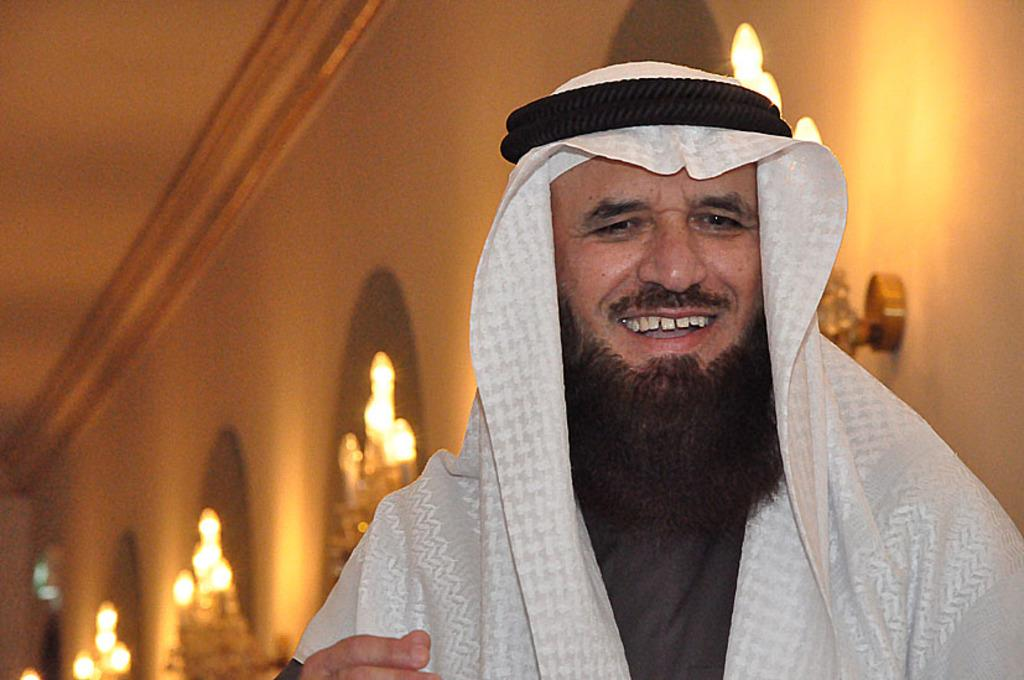Who is present in the image? There is a man in the image. What expression does the man have? The man is smiling. Can you describe the background of the image? The background of the image is blurry, and there are lights and a wall visible. What type of cherry is the man holding in the image? There is no cherry present in the image; the man is not holding anything. What word is written on the wall in the background? There is no word visible on the wall in the background of the image. 